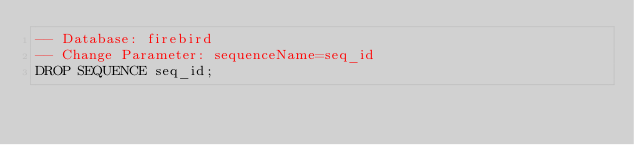<code> <loc_0><loc_0><loc_500><loc_500><_SQL_>-- Database: firebird
-- Change Parameter: sequenceName=seq_id
DROP SEQUENCE seq_id;
</code> 